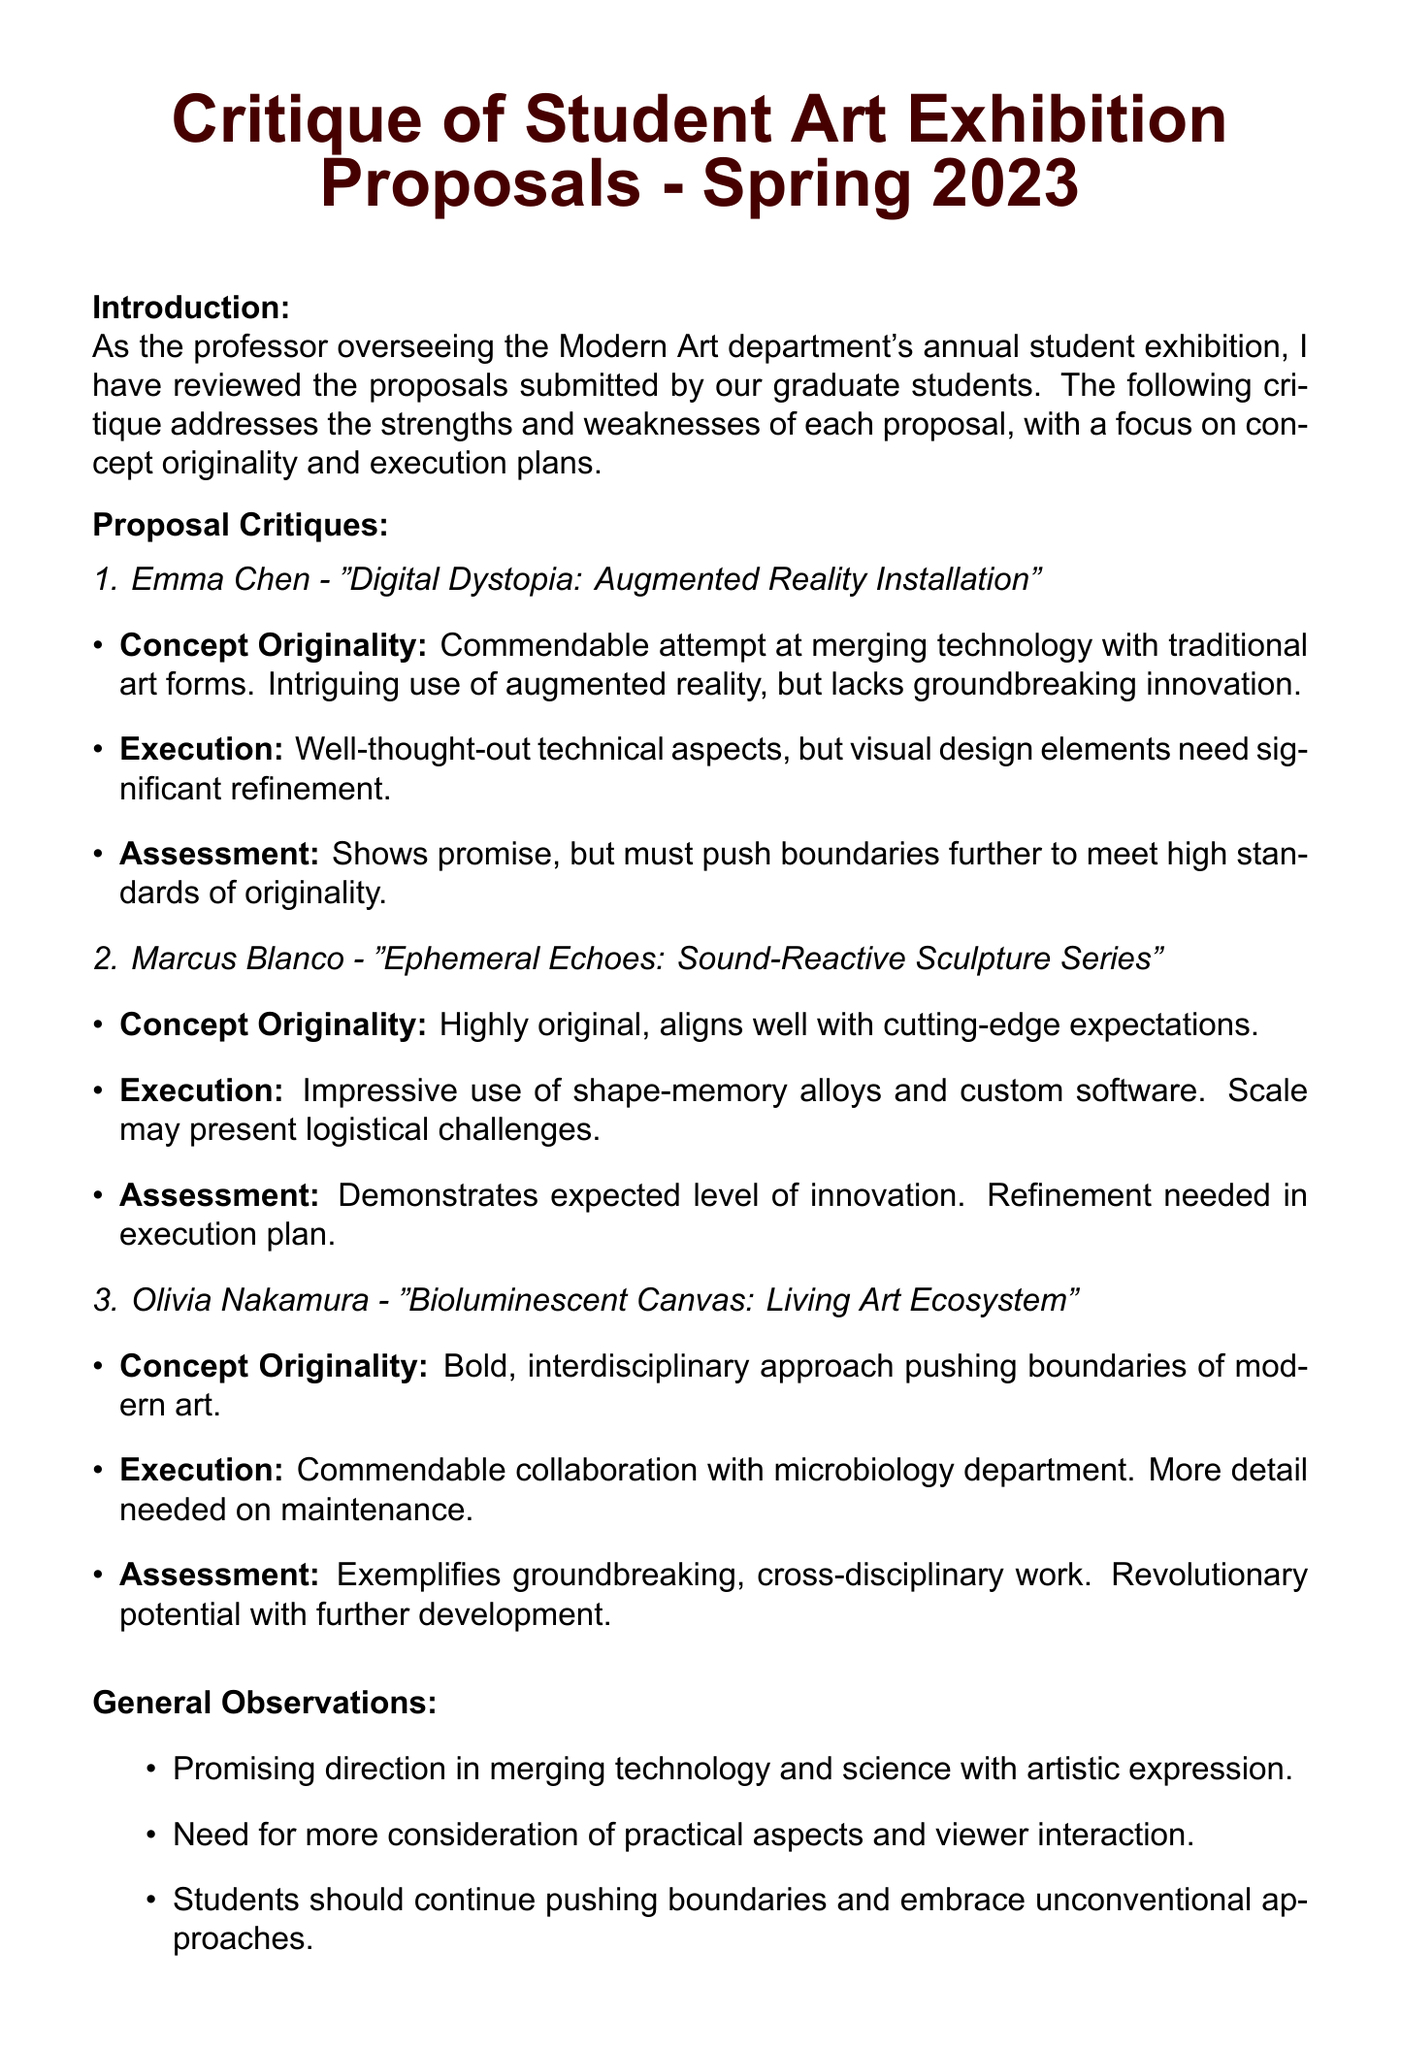What is the title of the memo? The title of the memo is explicitly stated at the beginning of the document.
Answer: Critique of Student Art Exhibition Proposals - Spring 2023 Who submitted a proposal for "Digital Dystopia: Augmented Reality Installation"? The student's name associated with this proposal is mentioned in the critique section.
Answer: Emma Chen What is the main technological element used in Marcus Blanco's proposal? The proposal specifies the use of a specific technology that is central to its concept.
Answer: Sound-reactive sculptures Which student proposed a living artwork using bioluminescent bacteria? The document lists the student associated with this unique artistic approach under the proposal critiques.
Answer: Olivia Nakamura What is one logistical challenge mentioned in Marcus Blanco's proposal? The execution feedback highlights a potential issue regarding the scale of the installation.
Answer: Logistical challenges What is a commendable aspect of Olivia Nakamura's proposal? The document identifies a positive collaboration that enhances her proposal's credibility.
Answer: Collaboration with the university's microbiology department What does the conclusion suggest about some of the proposals? The conclusion summarizes the overall quality and expectations for the proposals within the exhibition context.
Answer: Require significant refinement What is one recommendation made for students regarding their technical aspects? The recommendations section provides specific advice aimed at improving students' proposals.
Answer: Seek input from experts in related fields 